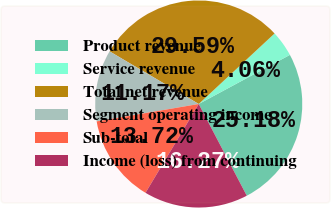Convert chart. <chart><loc_0><loc_0><loc_500><loc_500><pie_chart><fcel>Product revenue<fcel>Service revenue<fcel>Total net revenue<fcel>Segment operating income<fcel>Sub-total<fcel>Income (loss) from continuing<nl><fcel>25.18%<fcel>4.06%<fcel>29.59%<fcel>11.17%<fcel>13.72%<fcel>16.27%<nl></chart> 